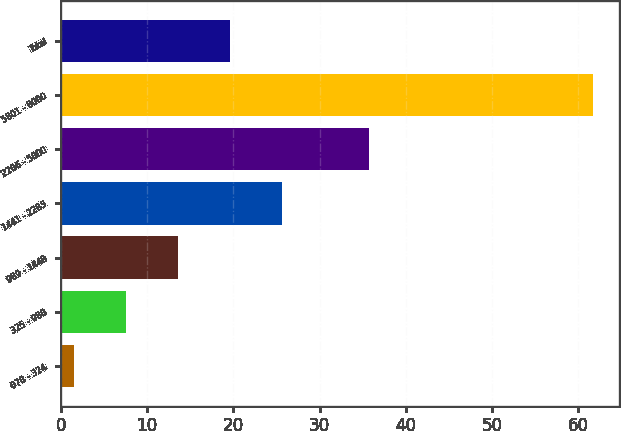Convert chart to OTSL. <chart><loc_0><loc_0><loc_500><loc_500><bar_chart><fcel>078 - 324<fcel>325 - 988<fcel>989 - 1440<fcel>1441 - 2285<fcel>2286 - 5800<fcel>5801 - 8000<fcel>Total<nl><fcel>1.6<fcel>7.61<fcel>13.62<fcel>25.64<fcel>35.75<fcel>61.66<fcel>19.63<nl></chart> 